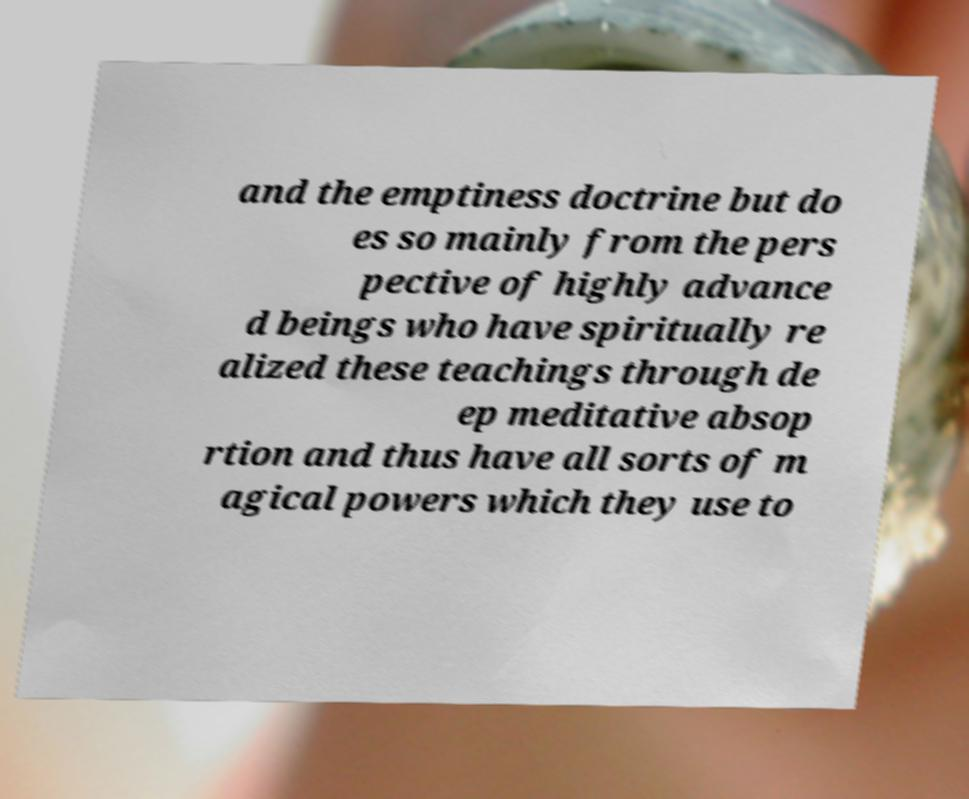Can you accurately transcribe the text from the provided image for me? and the emptiness doctrine but do es so mainly from the pers pective of highly advance d beings who have spiritually re alized these teachings through de ep meditative absop rtion and thus have all sorts of m agical powers which they use to 